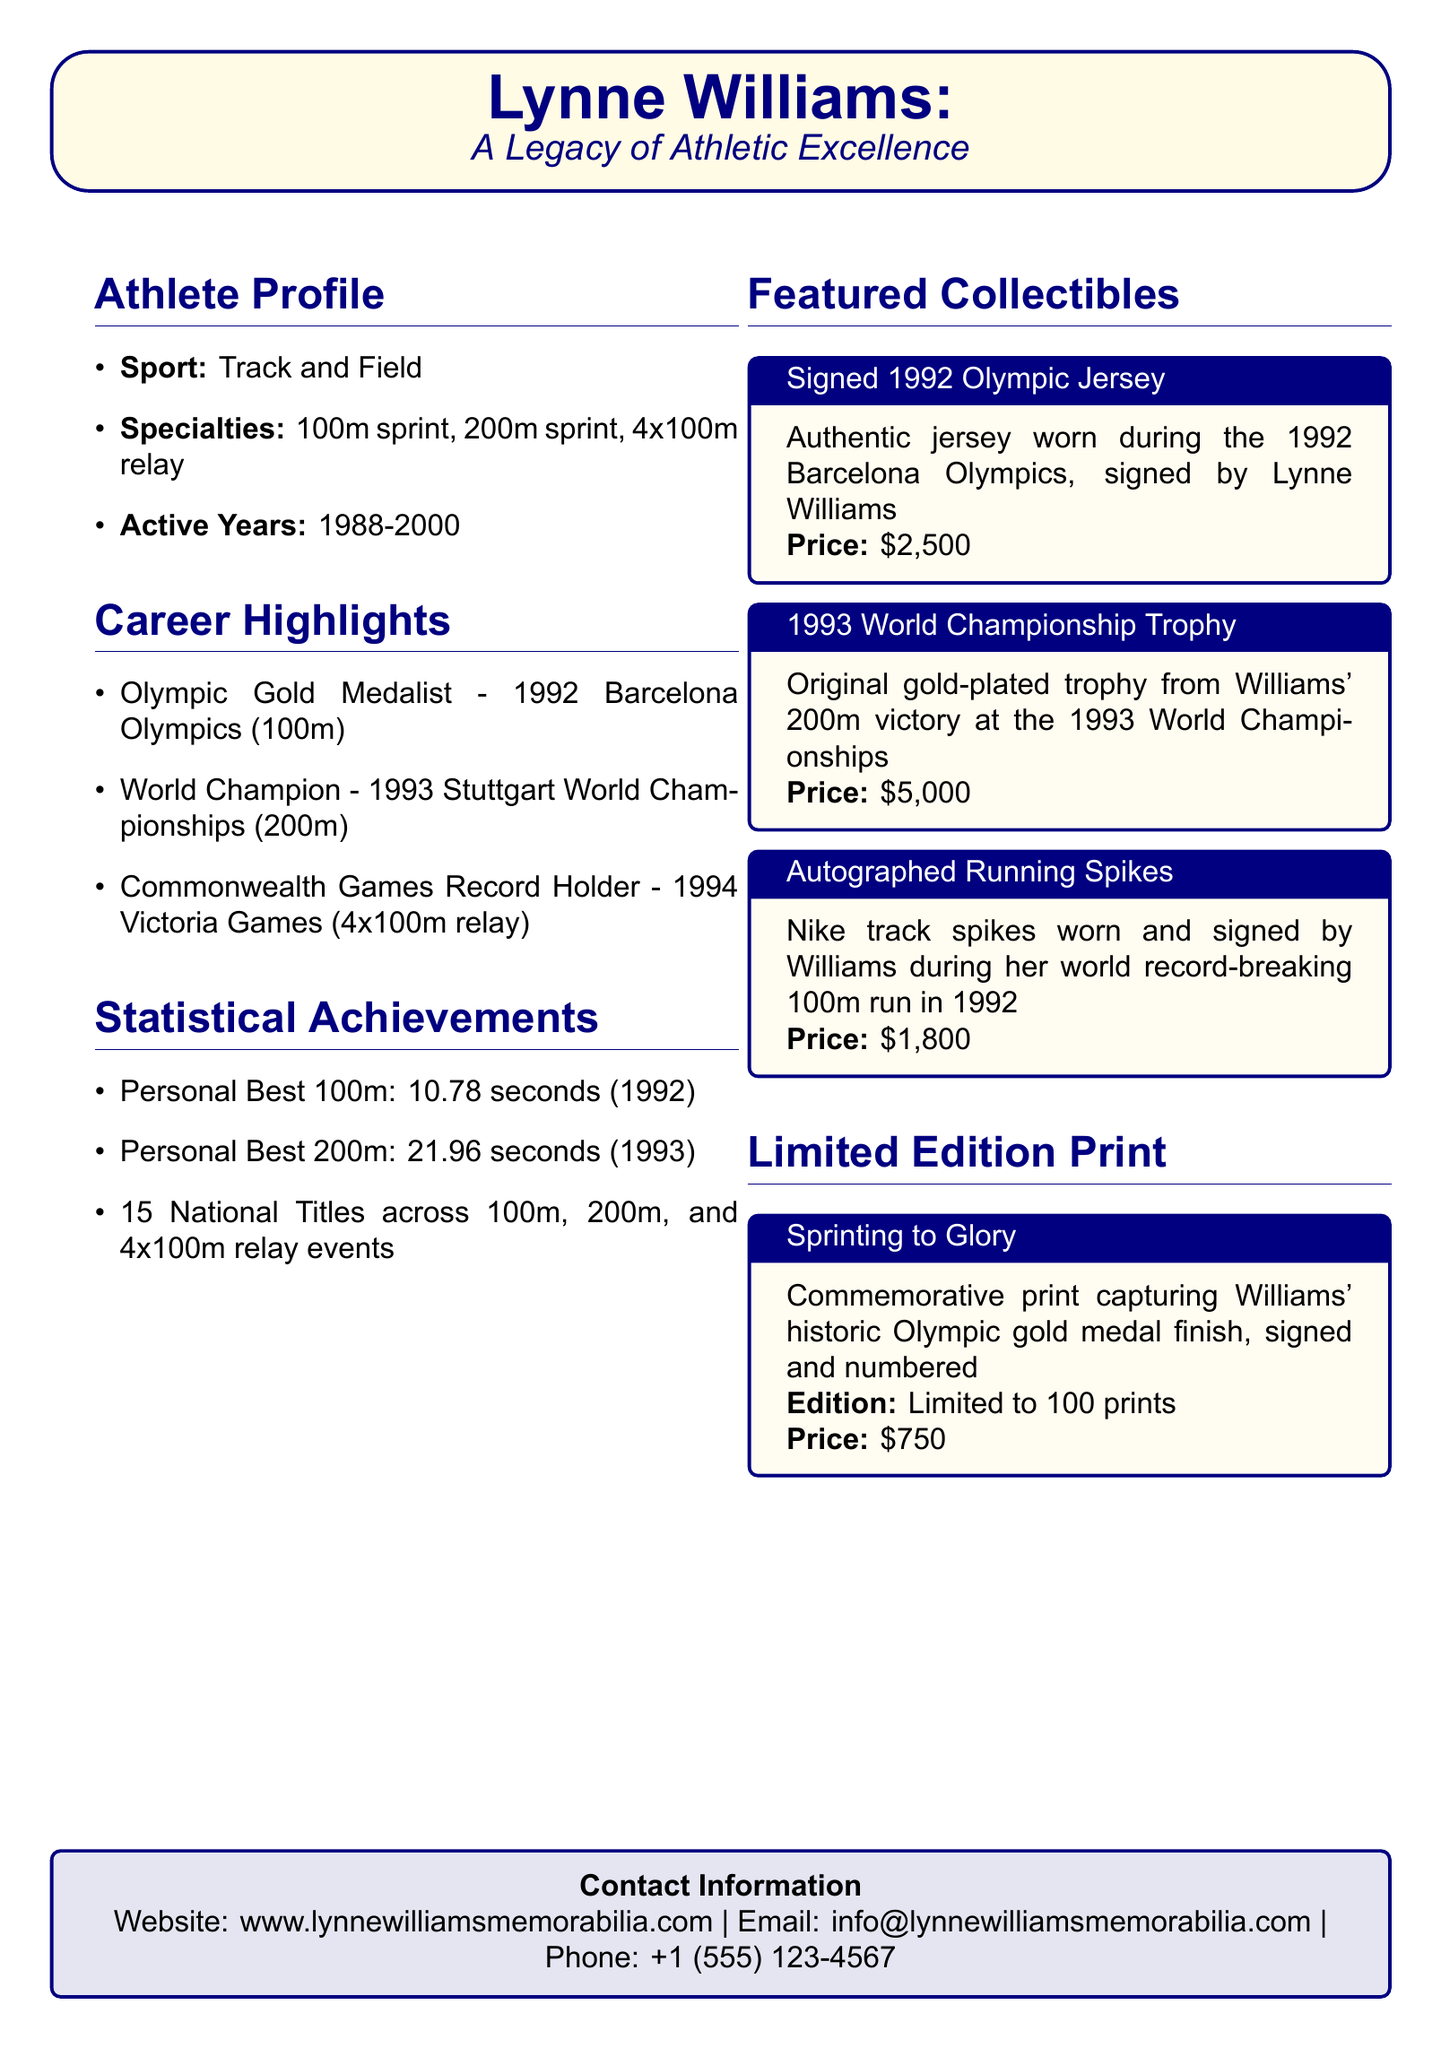What sport did Lynne Williams compete in? The document states that Lynne Williams was involved in Track and Field.
Answer: Track and Field What year did Lynne Williams win a gold medal at the Olympics? The document mentions she won an Olympic gold medal in 1992.
Answer: 1992 How many national titles did Lynne Williams achieve? The document lists 15 national titles achieved by Lynne Williams.
Answer: 15 What was Lynne Williams' personal best time in the 100m sprint? The document states her personal best for the 100m was 10.78 seconds.
Answer: 10.78 seconds What is the price of the signed 1992 Olympic jersey? The document specifies that the price for the signed jersey is $2,500.
Answer: $2,500 What significant achievement did Lynne Williams accomplish at the 1994 Commonwealth Games? The document indicates she was a record holder in the 4x100m relay.
Answer: Record Holder Which collectible has a price of $1,800? The document details that the autographed running spikes are priced at $1,800.
Answer: Autographed Running Spikes How many limited edition prints are available? The document specifies that there are 100 prints in total.
Answer: 100 prints What is the website for Lynne Williams memorabilia? The document provides the website as www.lynnewilliamsmemorabilia.com.
Answer: www.lynnewilliamsmemorabilia.com 